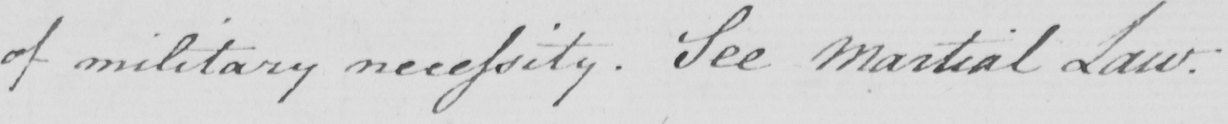What is written in this line of handwriting? of military necessity . See Martial Law : 